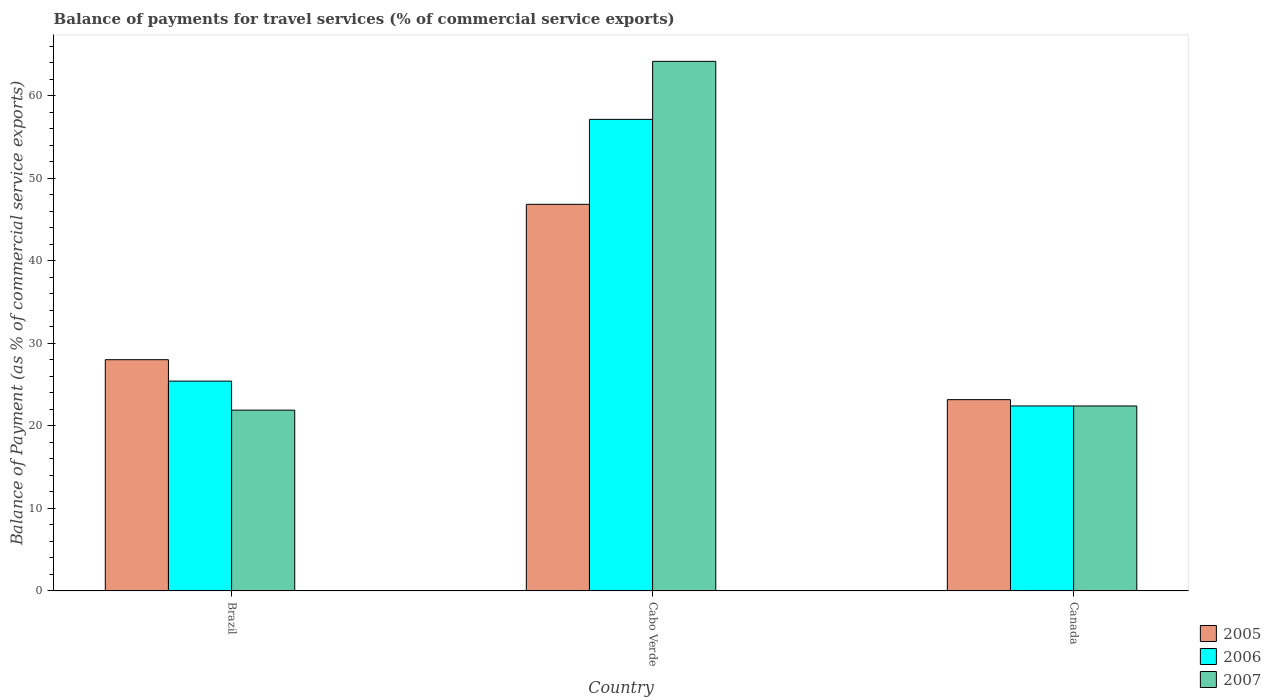How many different coloured bars are there?
Provide a short and direct response. 3. Are the number of bars per tick equal to the number of legend labels?
Make the answer very short. Yes. What is the balance of payments for travel services in 2006 in Cabo Verde?
Your response must be concise. 57.13. Across all countries, what is the maximum balance of payments for travel services in 2007?
Keep it short and to the point. 64.16. Across all countries, what is the minimum balance of payments for travel services in 2007?
Make the answer very short. 21.9. In which country was the balance of payments for travel services in 2005 maximum?
Keep it short and to the point. Cabo Verde. What is the total balance of payments for travel services in 2005 in the graph?
Keep it short and to the point. 98.03. What is the difference between the balance of payments for travel services in 2005 in Brazil and that in Cabo Verde?
Offer a very short reply. -18.82. What is the difference between the balance of payments for travel services in 2006 in Brazil and the balance of payments for travel services in 2005 in Canada?
Your answer should be compact. 2.25. What is the average balance of payments for travel services in 2007 per country?
Offer a very short reply. 36.16. What is the difference between the balance of payments for travel services of/in 2007 and balance of payments for travel services of/in 2005 in Cabo Verde?
Keep it short and to the point. 17.32. What is the ratio of the balance of payments for travel services in 2006 in Brazil to that in Canada?
Give a very brief answer. 1.13. Is the balance of payments for travel services in 2007 in Brazil less than that in Cabo Verde?
Provide a succinct answer. Yes. Is the difference between the balance of payments for travel services in 2007 in Cabo Verde and Canada greater than the difference between the balance of payments for travel services in 2005 in Cabo Verde and Canada?
Keep it short and to the point. Yes. What is the difference between the highest and the second highest balance of payments for travel services in 2007?
Provide a short and direct response. 42.26. What is the difference between the highest and the lowest balance of payments for travel services in 2006?
Make the answer very short. 34.72. In how many countries, is the balance of payments for travel services in 2007 greater than the average balance of payments for travel services in 2007 taken over all countries?
Ensure brevity in your answer.  1. What does the 3rd bar from the right in Canada represents?
Give a very brief answer. 2005. Is it the case that in every country, the sum of the balance of payments for travel services in 2006 and balance of payments for travel services in 2007 is greater than the balance of payments for travel services in 2005?
Make the answer very short. Yes. How many bars are there?
Provide a succinct answer. 9. How many countries are there in the graph?
Provide a short and direct response. 3. What is the difference between two consecutive major ticks on the Y-axis?
Keep it short and to the point. 10. Are the values on the major ticks of Y-axis written in scientific E-notation?
Give a very brief answer. No. Does the graph contain any zero values?
Provide a succinct answer. No. Does the graph contain grids?
Provide a succinct answer. No. How many legend labels are there?
Your answer should be compact. 3. How are the legend labels stacked?
Make the answer very short. Vertical. What is the title of the graph?
Provide a short and direct response. Balance of payments for travel services (% of commercial service exports). What is the label or title of the X-axis?
Your response must be concise. Country. What is the label or title of the Y-axis?
Your answer should be compact. Balance of Payment (as % of commercial service exports). What is the Balance of Payment (as % of commercial service exports) in 2005 in Brazil?
Offer a very short reply. 28.01. What is the Balance of Payment (as % of commercial service exports) in 2006 in Brazil?
Provide a short and direct response. 25.42. What is the Balance of Payment (as % of commercial service exports) in 2007 in Brazil?
Make the answer very short. 21.9. What is the Balance of Payment (as % of commercial service exports) of 2005 in Cabo Verde?
Make the answer very short. 46.84. What is the Balance of Payment (as % of commercial service exports) of 2006 in Cabo Verde?
Offer a terse response. 57.13. What is the Balance of Payment (as % of commercial service exports) in 2007 in Cabo Verde?
Make the answer very short. 64.16. What is the Balance of Payment (as % of commercial service exports) in 2005 in Canada?
Provide a succinct answer. 23.17. What is the Balance of Payment (as % of commercial service exports) of 2006 in Canada?
Your response must be concise. 22.41. What is the Balance of Payment (as % of commercial service exports) of 2007 in Canada?
Make the answer very short. 22.41. Across all countries, what is the maximum Balance of Payment (as % of commercial service exports) in 2005?
Give a very brief answer. 46.84. Across all countries, what is the maximum Balance of Payment (as % of commercial service exports) in 2006?
Your answer should be compact. 57.13. Across all countries, what is the maximum Balance of Payment (as % of commercial service exports) of 2007?
Provide a succinct answer. 64.16. Across all countries, what is the minimum Balance of Payment (as % of commercial service exports) of 2005?
Provide a succinct answer. 23.17. Across all countries, what is the minimum Balance of Payment (as % of commercial service exports) of 2006?
Make the answer very short. 22.41. Across all countries, what is the minimum Balance of Payment (as % of commercial service exports) of 2007?
Your answer should be compact. 21.9. What is the total Balance of Payment (as % of commercial service exports) in 2005 in the graph?
Provide a succinct answer. 98.03. What is the total Balance of Payment (as % of commercial service exports) of 2006 in the graph?
Offer a very short reply. 104.96. What is the total Balance of Payment (as % of commercial service exports) of 2007 in the graph?
Give a very brief answer. 108.47. What is the difference between the Balance of Payment (as % of commercial service exports) of 2005 in Brazil and that in Cabo Verde?
Keep it short and to the point. -18.82. What is the difference between the Balance of Payment (as % of commercial service exports) in 2006 in Brazil and that in Cabo Verde?
Give a very brief answer. -31.71. What is the difference between the Balance of Payment (as % of commercial service exports) of 2007 in Brazil and that in Cabo Verde?
Provide a succinct answer. -42.26. What is the difference between the Balance of Payment (as % of commercial service exports) of 2005 in Brazil and that in Canada?
Offer a terse response. 4.84. What is the difference between the Balance of Payment (as % of commercial service exports) of 2006 in Brazil and that in Canada?
Offer a very short reply. 3.01. What is the difference between the Balance of Payment (as % of commercial service exports) of 2007 in Brazil and that in Canada?
Offer a terse response. -0.51. What is the difference between the Balance of Payment (as % of commercial service exports) of 2005 in Cabo Verde and that in Canada?
Your answer should be compact. 23.66. What is the difference between the Balance of Payment (as % of commercial service exports) of 2006 in Cabo Verde and that in Canada?
Keep it short and to the point. 34.72. What is the difference between the Balance of Payment (as % of commercial service exports) in 2007 in Cabo Verde and that in Canada?
Keep it short and to the point. 41.75. What is the difference between the Balance of Payment (as % of commercial service exports) in 2005 in Brazil and the Balance of Payment (as % of commercial service exports) in 2006 in Cabo Verde?
Your response must be concise. -29.12. What is the difference between the Balance of Payment (as % of commercial service exports) of 2005 in Brazil and the Balance of Payment (as % of commercial service exports) of 2007 in Cabo Verde?
Give a very brief answer. -36.15. What is the difference between the Balance of Payment (as % of commercial service exports) in 2006 in Brazil and the Balance of Payment (as % of commercial service exports) in 2007 in Cabo Verde?
Keep it short and to the point. -38.74. What is the difference between the Balance of Payment (as % of commercial service exports) of 2005 in Brazil and the Balance of Payment (as % of commercial service exports) of 2006 in Canada?
Ensure brevity in your answer.  5.6. What is the difference between the Balance of Payment (as % of commercial service exports) in 2005 in Brazil and the Balance of Payment (as % of commercial service exports) in 2007 in Canada?
Give a very brief answer. 5.61. What is the difference between the Balance of Payment (as % of commercial service exports) of 2006 in Brazil and the Balance of Payment (as % of commercial service exports) of 2007 in Canada?
Provide a succinct answer. 3.01. What is the difference between the Balance of Payment (as % of commercial service exports) in 2005 in Cabo Verde and the Balance of Payment (as % of commercial service exports) in 2006 in Canada?
Your answer should be very brief. 24.43. What is the difference between the Balance of Payment (as % of commercial service exports) of 2005 in Cabo Verde and the Balance of Payment (as % of commercial service exports) of 2007 in Canada?
Keep it short and to the point. 24.43. What is the difference between the Balance of Payment (as % of commercial service exports) of 2006 in Cabo Verde and the Balance of Payment (as % of commercial service exports) of 2007 in Canada?
Make the answer very short. 34.72. What is the average Balance of Payment (as % of commercial service exports) of 2005 per country?
Make the answer very short. 32.68. What is the average Balance of Payment (as % of commercial service exports) in 2006 per country?
Offer a very short reply. 34.99. What is the average Balance of Payment (as % of commercial service exports) of 2007 per country?
Ensure brevity in your answer.  36.16. What is the difference between the Balance of Payment (as % of commercial service exports) in 2005 and Balance of Payment (as % of commercial service exports) in 2006 in Brazil?
Your answer should be compact. 2.59. What is the difference between the Balance of Payment (as % of commercial service exports) in 2005 and Balance of Payment (as % of commercial service exports) in 2007 in Brazil?
Offer a very short reply. 6.11. What is the difference between the Balance of Payment (as % of commercial service exports) of 2006 and Balance of Payment (as % of commercial service exports) of 2007 in Brazil?
Provide a succinct answer. 3.52. What is the difference between the Balance of Payment (as % of commercial service exports) in 2005 and Balance of Payment (as % of commercial service exports) in 2006 in Cabo Verde?
Keep it short and to the point. -10.29. What is the difference between the Balance of Payment (as % of commercial service exports) of 2005 and Balance of Payment (as % of commercial service exports) of 2007 in Cabo Verde?
Ensure brevity in your answer.  -17.32. What is the difference between the Balance of Payment (as % of commercial service exports) in 2006 and Balance of Payment (as % of commercial service exports) in 2007 in Cabo Verde?
Keep it short and to the point. -7.03. What is the difference between the Balance of Payment (as % of commercial service exports) of 2005 and Balance of Payment (as % of commercial service exports) of 2006 in Canada?
Offer a terse response. 0.76. What is the difference between the Balance of Payment (as % of commercial service exports) in 2005 and Balance of Payment (as % of commercial service exports) in 2007 in Canada?
Your answer should be compact. 0.77. What is the difference between the Balance of Payment (as % of commercial service exports) of 2006 and Balance of Payment (as % of commercial service exports) of 2007 in Canada?
Your answer should be compact. 0. What is the ratio of the Balance of Payment (as % of commercial service exports) in 2005 in Brazil to that in Cabo Verde?
Your response must be concise. 0.6. What is the ratio of the Balance of Payment (as % of commercial service exports) of 2006 in Brazil to that in Cabo Verde?
Your response must be concise. 0.44. What is the ratio of the Balance of Payment (as % of commercial service exports) of 2007 in Brazil to that in Cabo Verde?
Your response must be concise. 0.34. What is the ratio of the Balance of Payment (as % of commercial service exports) in 2005 in Brazil to that in Canada?
Offer a terse response. 1.21. What is the ratio of the Balance of Payment (as % of commercial service exports) in 2006 in Brazil to that in Canada?
Provide a short and direct response. 1.13. What is the ratio of the Balance of Payment (as % of commercial service exports) of 2007 in Brazil to that in Canada?
Keep it short and to the point. 0.98. What is the ratio of the Balance of Payment (as % of commercial service exports) in 2005 in Cabo Verde to that in Canada?
Offer a terse response. 2.02. What is the ratio of the Balance of Payment (as % of commercial service exports) of 2006 in Cabo Verde to that in Canada?
Ensure brevity in your answer.  2.55. What is the ratio of the Balance of Payment (as % of commercial service exports) of 2007 in Cabo Verde to that in Canada?
Your answer should be very brief. 2.86. What is the difference between the highest and the second highest Balance of Payment (as % of commercial service exports) of 2005?
Provide a succinct answer. 18.82. What is the difference between the highest and the second highest Balance of Payment (as % of commercial service exports) of 2006?
Your answer should be compact. 31.71. What is the difference between the highest and the second highest Balance of Payment (as % of commercial service exports) in 2007?
Offer a terse response. 41.75. What is the difference between the highest and the lowest Balance of Payment (as % of commercial service exports) in 2005?
Provide a short and direct response. 23.66. What is the difference between the highest and the lowest Balance of Payment (as % of commercial service exports) of 2006?
Your answer should be very brief. 34.72. What is the difference between the highest and the lowest Balance of Payment (as % of commercial service exports) of 2007?
Provide a succinct answer. 42.26. 